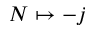<formula> <loc_0><loc_0><loc_500><loc_500>N \mapsto - j</formula> 